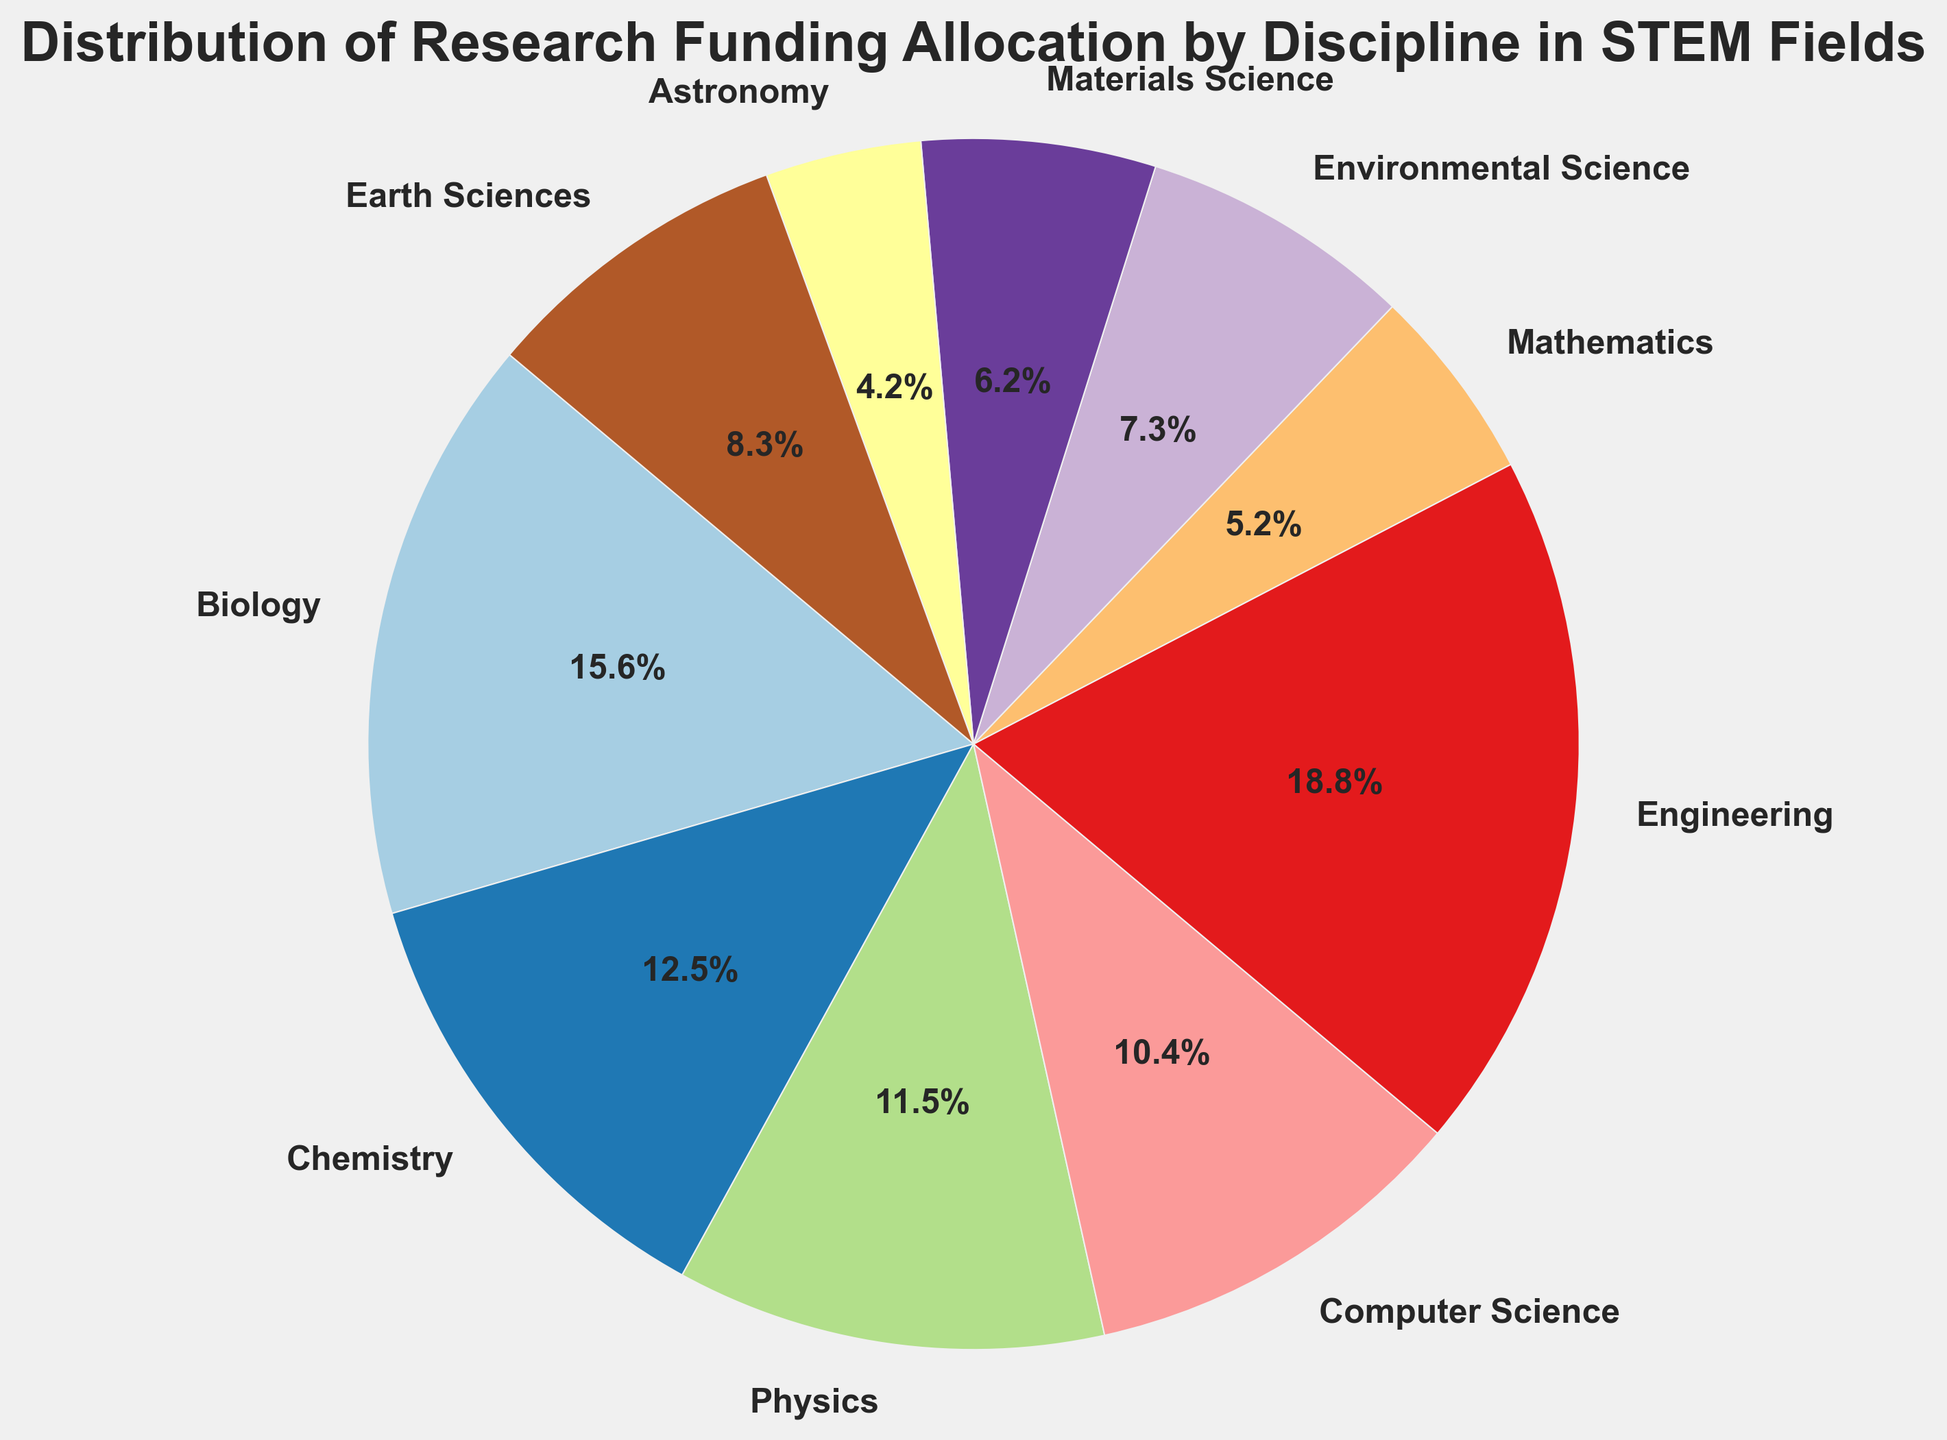Which discipline receives the highest amount of research funding? To determine which discipline receives the highest funding, look for the largest section of the pie chart. The Engineering section is the largest, indicating it receives the most funding.
Answer: Engineering Which discipline receives the lowest amount of research funding? To determine which discipline receives the lowest funding, look for the smallest section of the pie chart. The Astronomy section is the smallest, indicating it receives the least funding.
Answer: Astronomy How much more funding does Biology receive compared to Mathematics? To find out the difference in funding between Biology and Mathematics, subtract the funding amount for Mathematics from that of Biology. Biology receives 1500 million USD, and Mathematics receives 500 million USD. Thus, the difference is 1500 - 500 = 1000 million USD.
Answer: 1000 million USD What percentage of the total funding is allocated to Computer Science? To determine the percentage allocated to Computer Science, look at the labeled percentage on the pie chart corresponding to Computer Science. The section for Computer Science is labeled with its percentage share.
Answer: 10.0% Which disciplines receive more funding than Physics? To determine which disciplines receive more funding than Physics, compare the funding amounts for each discipline. Physics receives 1100 million USD; the disciplines with higher funding are Biology (1500 million USD), Chemistry (1200 million USD), Engineering (1800 million USD).
Answer: Biology, Chemistry, Engineering What is the sum of the funding amounts for Environmental Science and Earth Sciences? To find the total funding for Environmental Science and Earth Sciences, add their funding amounts. Environmental Science receives 700 million USD, and Earth Sciences receive 800 million USD. The total is 700 + 800 = 1500 million USD.
Answer: 1500 million USD How does the funding for Materials Science compare to that of Chemistry? To compare the funding for Materials Science and Chemistry, look at their respective funding amounts. Materials Science receives 600 million USD, while Chemistry receives 1200 million USD. Materials Science receives less than Chemistry.
Answer: Less What is the approximate difference in funding between Engineering and Computer Science? To find the difference in funding between Engineering and Computer Science, subtract the funding amount for Computer Science from that of Engineering. Engineering receives 1800 million USD, and Computer Science receives 1000 million USD.  The difference is 1800 - 1000 = 800 million USD.
Answer: 800 million USD What percentage of the total funding is allocated to disciplines receiving less than 1000 million USD? First, identify the disciplines receiving less than 1000 million USD: Mathematics (500 million USD), Environmental Science (700 million USD), Materials Science (600 million USD), Astronomy (400 million USD), and Earth Sciences (800 million USD). Then add their funding amounts: 500 + 700 + 600 + 400 + 800 = 3000 million USD. The total funding sum is the sum of all amounts in the pie chart. Calculate 3000 million USD as a percentage of the total funding. Total funding (sum of all disciplines): 9600 million USD. Percentage: (3000 / 9600) * 100 ≈ 31.3%.
Answer: 31.3% 